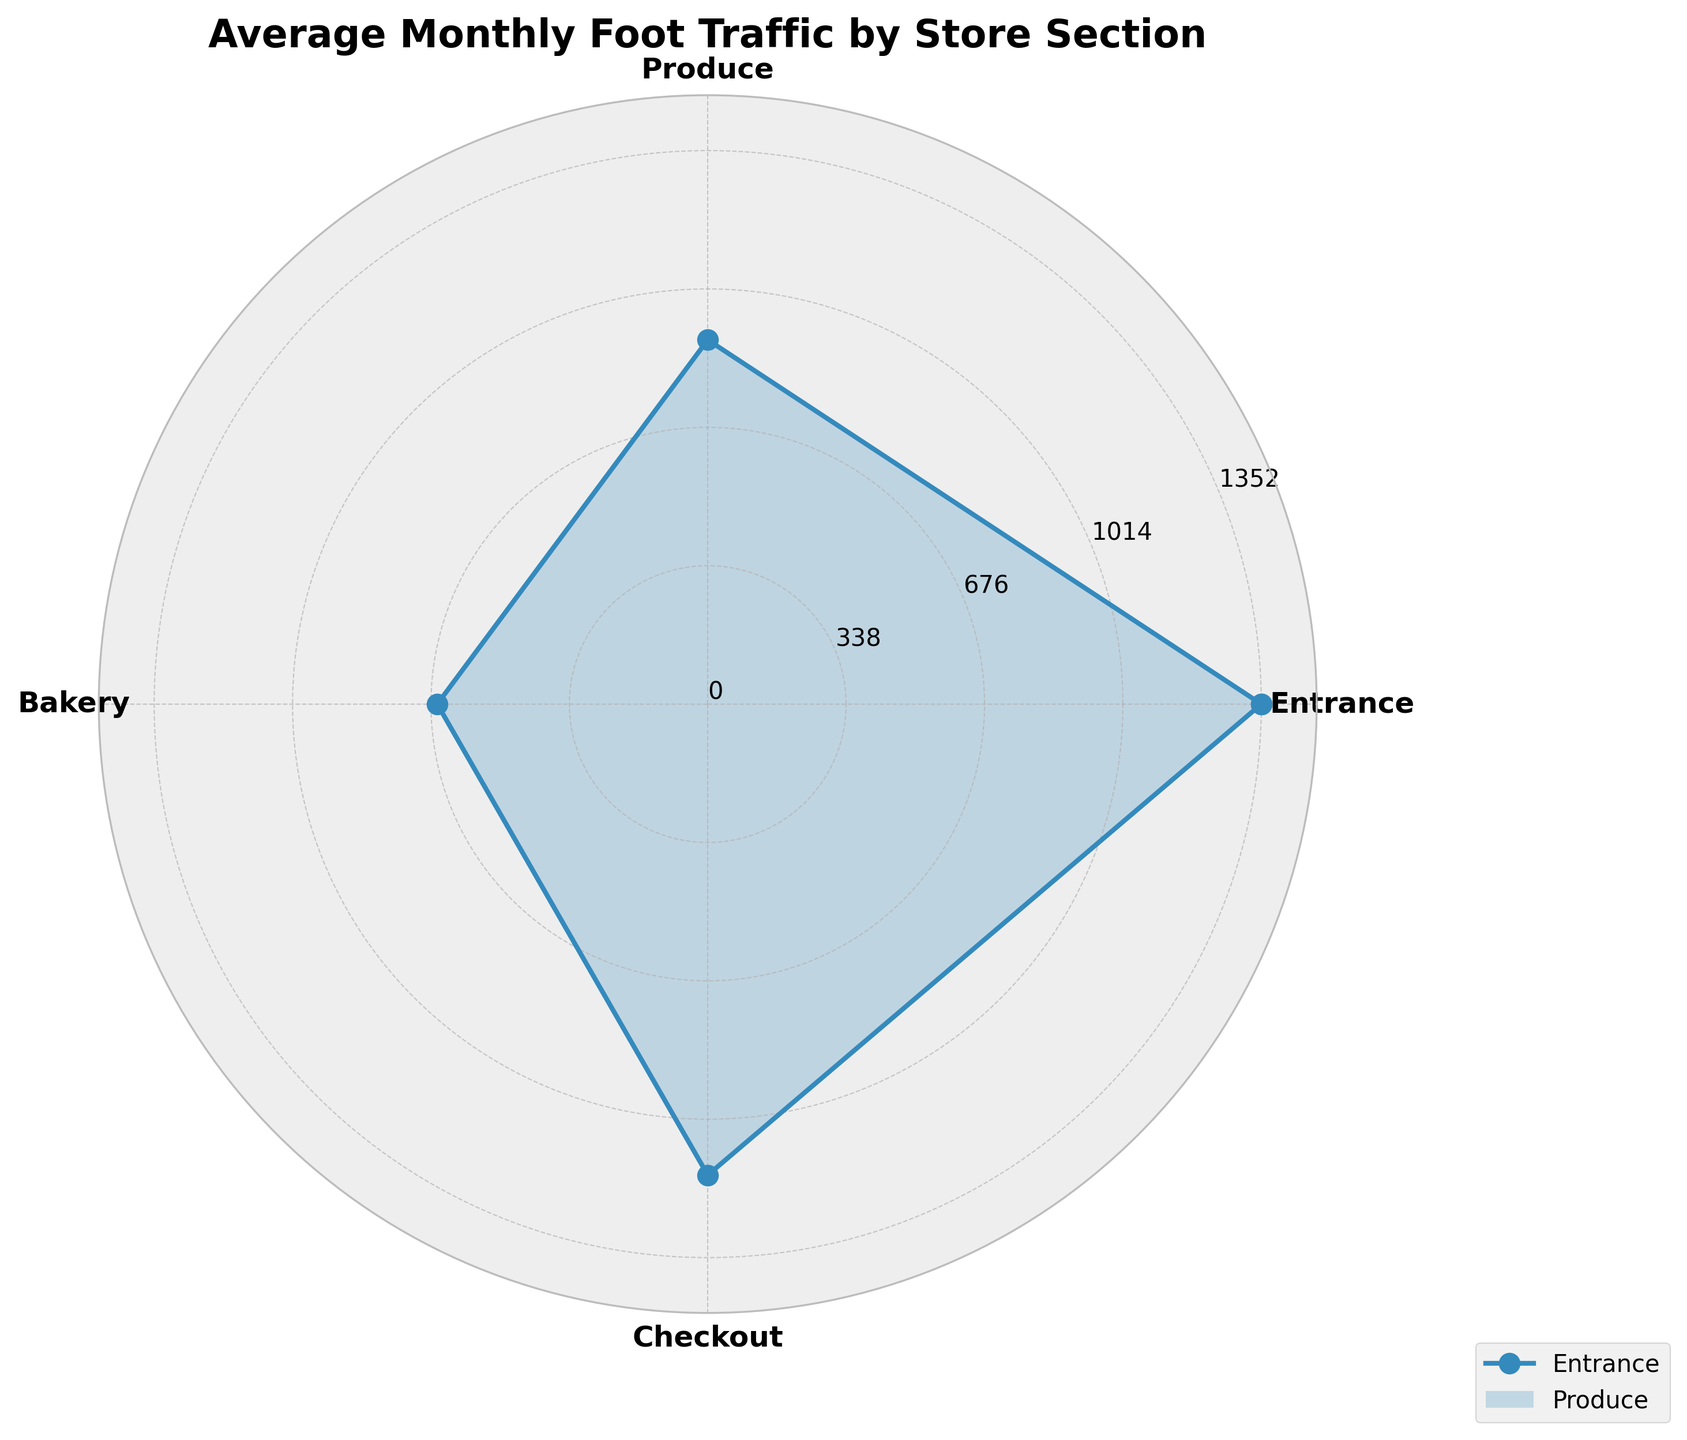What's the title of the figure? The title is found at the top of the figure and usually provides a summary of the chart contents. In this case, the title is larger and bolder to stand out.
Answer: Average Monthly Foot Traffic by Store Section Which section has the highest average monthly foot traffic? To determine the highest average, look for the section with the largest value along the rose chart. The values are represented by the lengths of the radial segments.
Answer: Entrance Which section has the lowest average monthly foot traffic? Look for the section with the smallest value along the rose chart. The values are represented by the lengths of the radial segments.
Answer: Bakery How does the average monthly foot traffic of the Checkout section compare to the Produce section? Compare the radial lengths of the Checkout and Produce sections. The longer the radial length, the higher the average foot traffic.
Answer: Checkout has higher foot traffic than Produce What's the sum of average foot traffic for Entrance and Bakery sections? Add the average monthly foot traffic values for Entrance and Bakery sections.
Answer: 1303 + 660 = 1963 Which section has a more evenly distributed traffic over the months, Produce or Bakery? Look at the radial lengths representing each month for Produce and Bakery. The section with more consistent length values across the months is more evenly distributed.
Answer: Produce Is the foot traffic at the Entrance higher in January or December? Compare the radial lengths representing January and December for the Entrance section.
Answer: December Considering all sections, which month tends to have the highest foot traffic? Examine the radial lengths for each month across all sections. Identify the month where the lengths are generally the longest.
Answer: December What is the difference in average foot traffic between the Entrance and Checkout sections? Subtract the average foot traffic value of the Checkout section from the Entrance section.
Answer: 1303 - 1149 = 154 